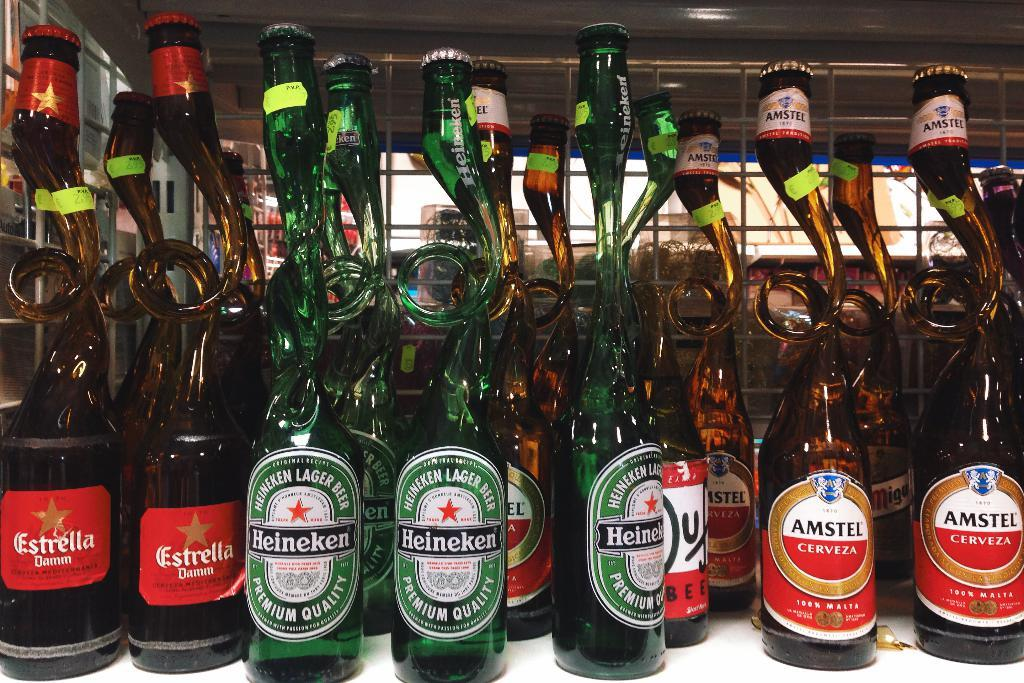<image>
Provide a brief description of the given image. a unusual bottle shape collection of Estrella, Heinekin and Amstel liquor. 